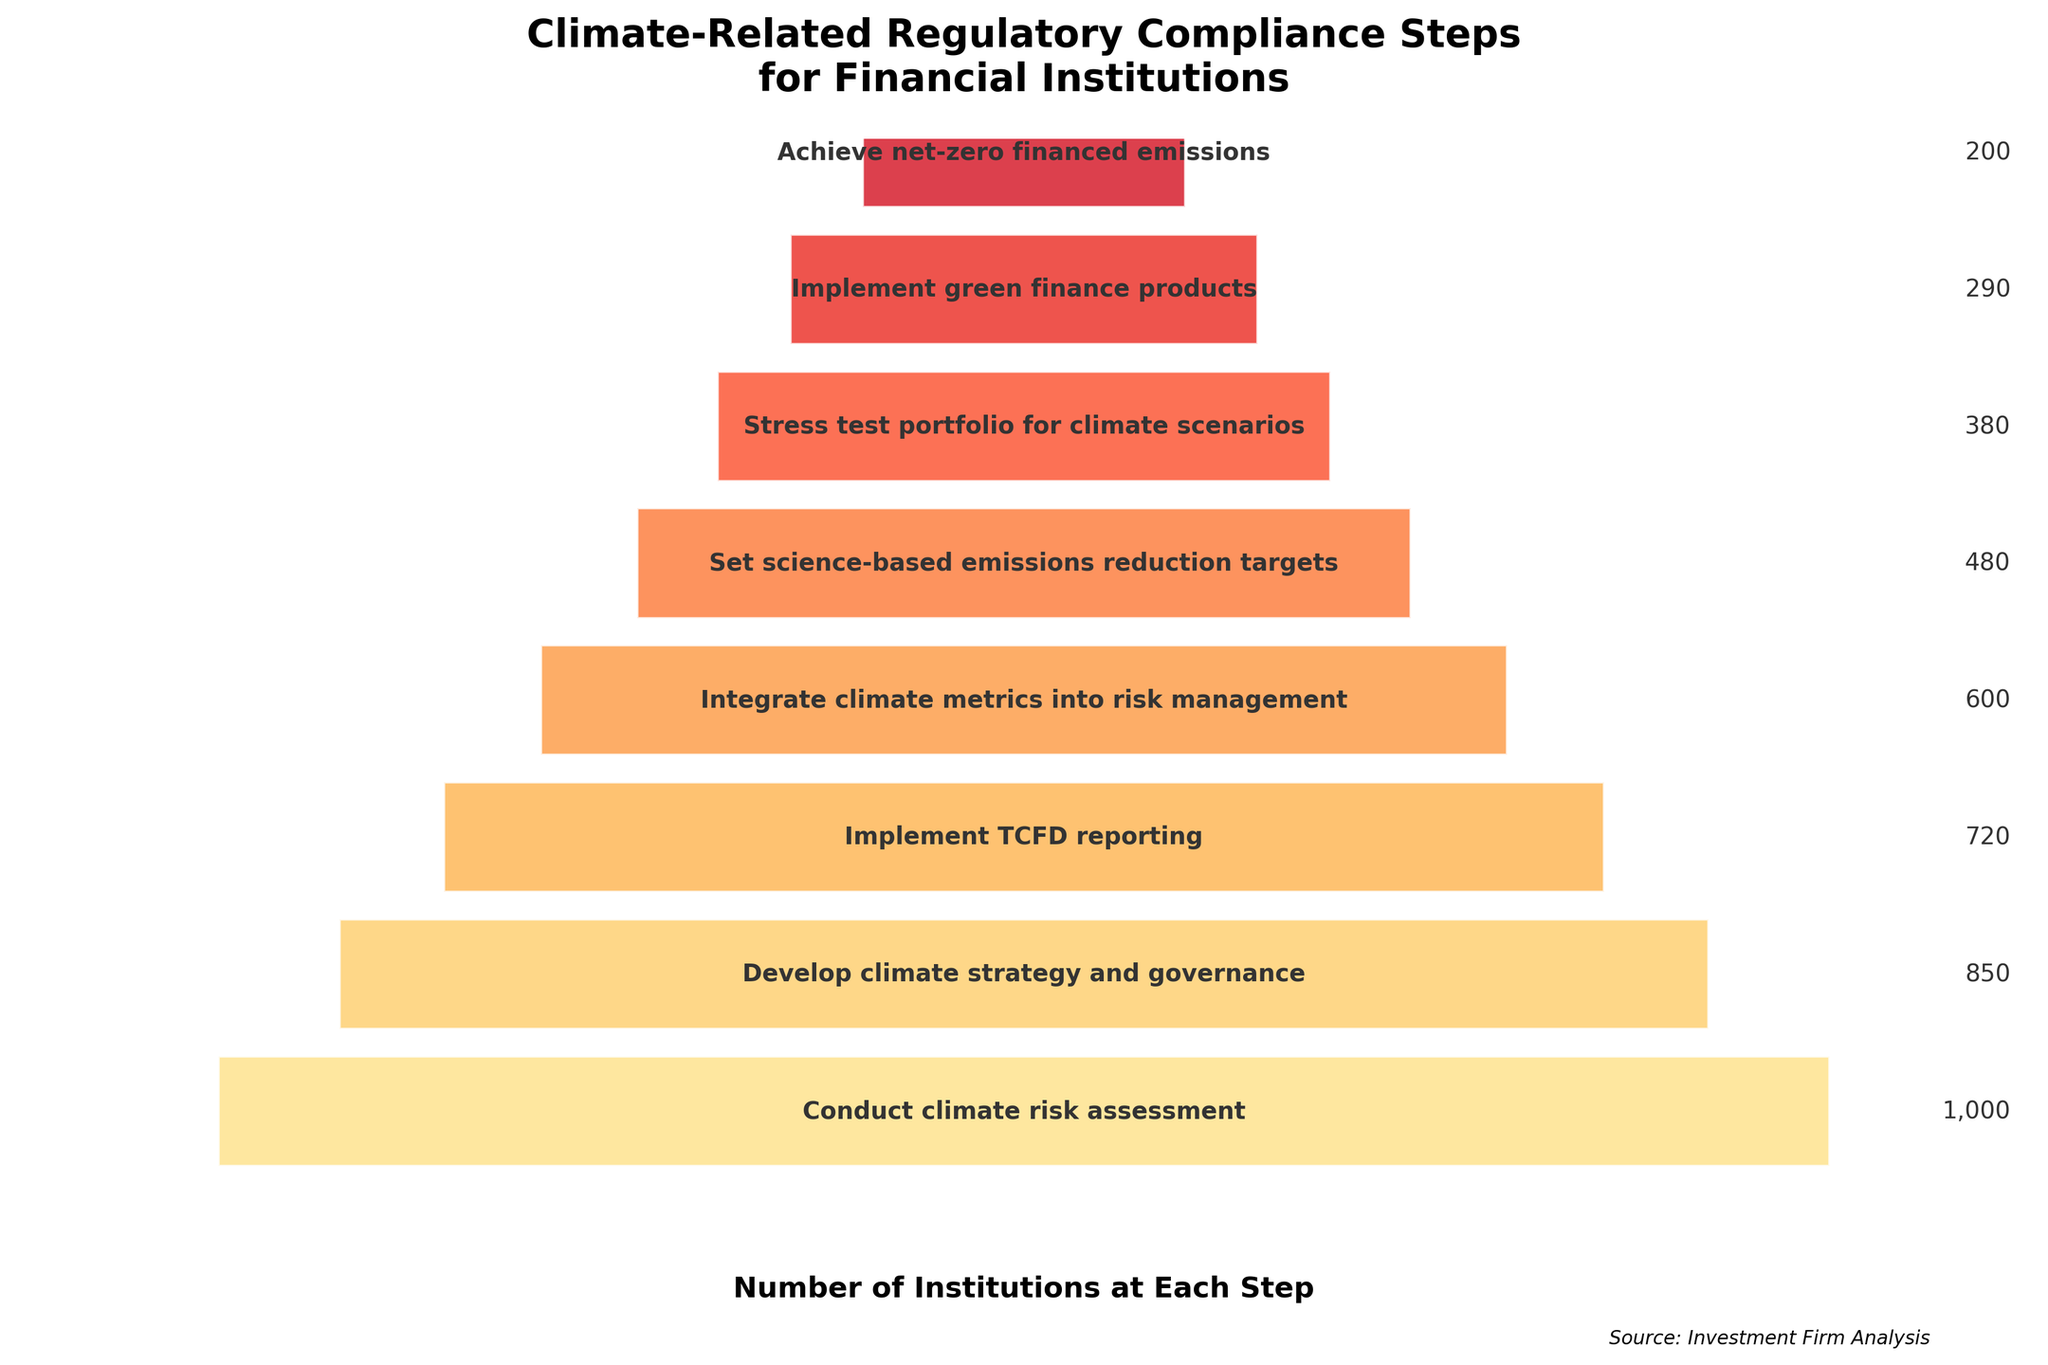How many financial institutions have conducted a climate risk assessment? The first step in the funnel chart is "Conduct climate risk assessment," and the number of institutions for this step is listed directly.
Answer: 1000 How many more institutions have implemented TCFD reporting compared to those that have achieved net-zero financed emissions? According to the chart, 720 institutions have implemented TCFD reporting, and 200 have achieved net-zero financed emissions. Subtract the latter from the former: 720 - 200 = 520.
Answer: 520 What is the difference in the number of institutions between setting science-based emissions reduction targets and implementing green finance products? The chart shows 480 institutions have set science-based emissions reduction targets, and 290 have implemented green finance products. Subtract 290 from 480: 480 - 290 = 190.
Answer: 190 Which step shows the largest drop in the number of institutions from the previous step? Comparing the differences between consecutive steps: 
- From 1000 to 850: 150 
- From 850 to 720: 130 
- From 720 to 600: 120 
- From 600 to 480: 120 
- From 480 to 380: 100 
- From 380 to 290: 90 
- From 290 to 200: 90 
The largest drop is 150, from the first to the second step.
Answer: Conduct climate risk assessment to Develop climate strategy and governance What is the average number of institutions involved across all compliance steps? To find the average, sum all the institution counts and divide by the number of steps: (1000 + 850 + 720 + 600 + 480 + 380 + 290 + 200) / 8 = 4520 / 8 = 565.
Answer: 565 What step occurs directly before integrating climate metrics into risk management? In the funnel chart, "Develop climate strategy and governance" occurs before "Integrate climate metrics into risk management."
Answer: Develop climate strategy and governance What is the smallest number of institutions at any step, and which step is it? The final step ("Achieve net-zero financed emissions") shows the smallest number of institutions, which is 200.
Answer: Achieve net-zero financed emissions, 200 Compare the number of institutions implementing TCFD reporting to those integrating climate metrics into risk management. Which is higher and by how much? The chart shows 720 institutions implementing TCFD reporting and 600 integrating climate metrics. Subtract the latter from the former: 720 - 600 = 120.
Answer: Implementing TCFD reporting by 120 